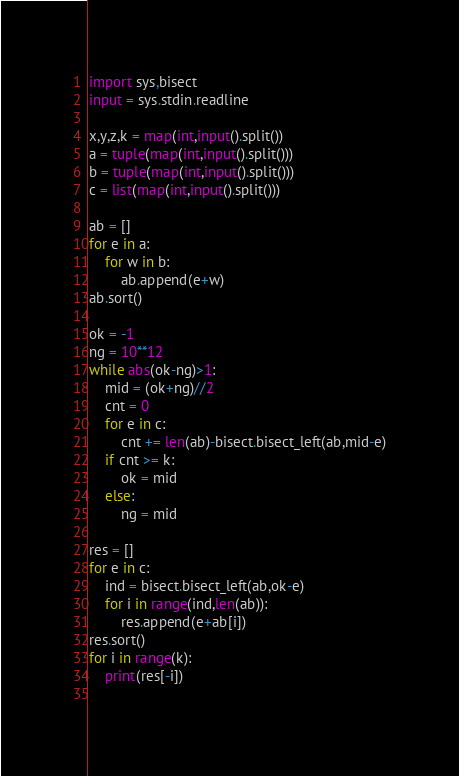<code> <loc_0><loc_0><loc_500><loc_500><_Python_>import sys,bisect
input = sys.stdin.readline

x,y,z,k = map(int,input().split())
a = tuple(map(int,input().split()))
b = tuple(map(int,input().split()))
c = list(map(int,input().split()))

ab = []
for e in a:
    for w in b:
        ab.append(e+w)
ab.sort()

ok = -1
ng = 10**12
while abs(ok-ng)>1:
    mid = (ok+ng)//2
    cnt = 0
    for e in c:
        cnt += len(ab)-bisect.bisect_left(ab,mid-e)
    if cnt >= k:
        ok = mid
    else:
        ng = mid

res = []
for e in c:
    ind = bisect.bisect_left(ab,ok-e)
    for i in range(ind,len(ab)):
        res.append(e+ab[i])
res.sort()
for i in range(k):
    print(res[-i])
        

</code> 